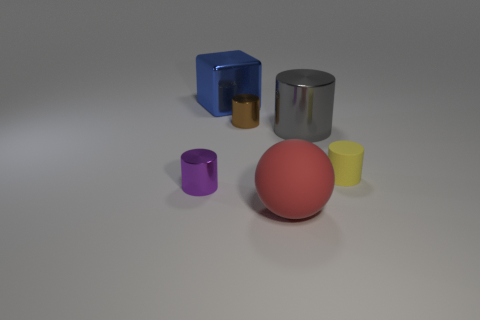What is the color of the matte thing that is the same size as the cube?
Ensure brevity in your answer.  Red. Is there a small blue cylinder made of the same material as the tiny yellow cylinder?
Ensure brevity in your answer.  No. Is there a small thing on the left side of the small metallic cylinder that is right of the purple metallic thing?
Your response must be concise. Yes. There is a cylinder that is right of the gray cylinder; what is it made of?
Ensure brevity in your answer.  Rubber. Is the small yellow object the same shape as the purple object?
Keep it short and to the point. Yes. There is a metal thing that is behind the small metallic object behind the metallic thing to the left of the big cube; what is its color?
Provide a succinct answer. Blue. What number of tiny cyan metallic objects are the same shape as the tiny yellow thing?
Make the answer very short. 0. There is a shiny object that is right of the small brown thing in front of the large blue block; what size is it?
Make the answer very short. Large. Is the red matte object the same size as the purple cylinder?
Your answer should be compact. No. There is a tiny metal cylinder behind the thing on the left side of the shiny cube; is there a gray metallic cylinder that is behind it?
Your response must be concise. No. 